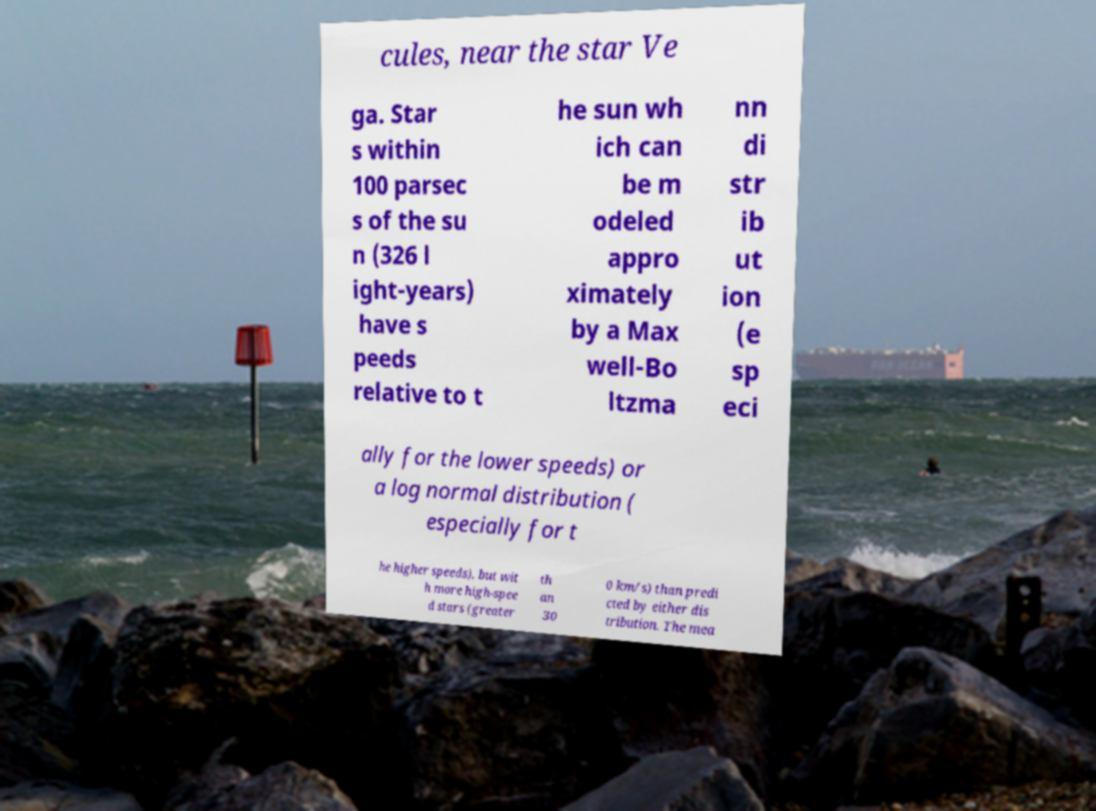I need the written content from this picture converted into text. Can you do that? cules, near the star Ve ga. Star s within 100 parsec s of the su n (326 l ight-years) have s peeds relative to t he sun wh ich can be m odeled appro ximately by a Max well-Bo ltzma nn di str ib ut ion (e sp eci ally for the lower speeds) or a log normal distribution ( especially for t he higher speeds), but wit h more high-spee d stars (greater th an 30 0 km/s) than predi cted by either dis tribution. The mea 